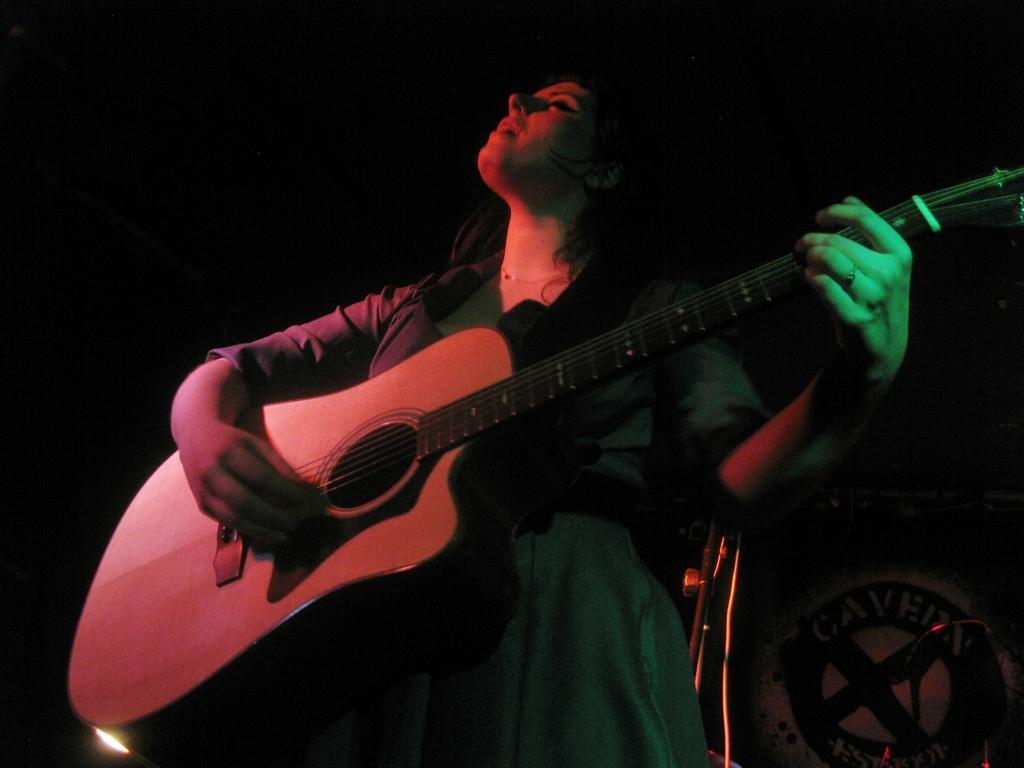Could you give a brief overview of what you see in this image? there is a woman playing guitar. 